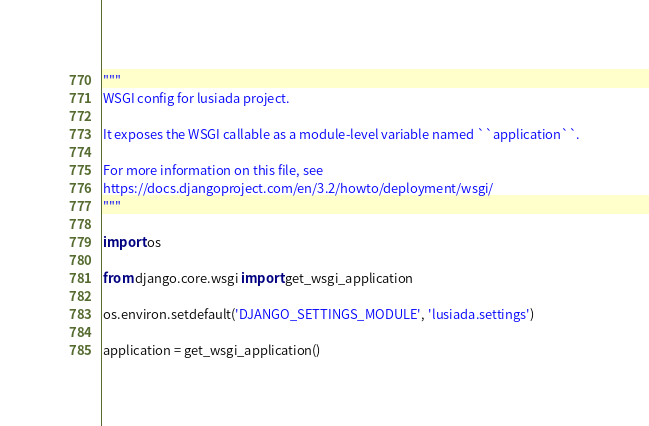Convert code to text. <code><loc_0><loc_0><loc_500><loc_500><_Python_>"""
WSGI config for lusiada project.

It exposes the WSGI callable as a module-level variable named ``application``.

For more information on this file, see
https://docs.djangoproject.com/en/3.2/howto/deployment/wsgi/
"""

import os

from django.core.wsgi import get_wsgi_application

os.environ.setdefault('DJANGO_SETTINGS_MODULE', 'lusiada.settings')

application = get_wsgi_application()
</code> 